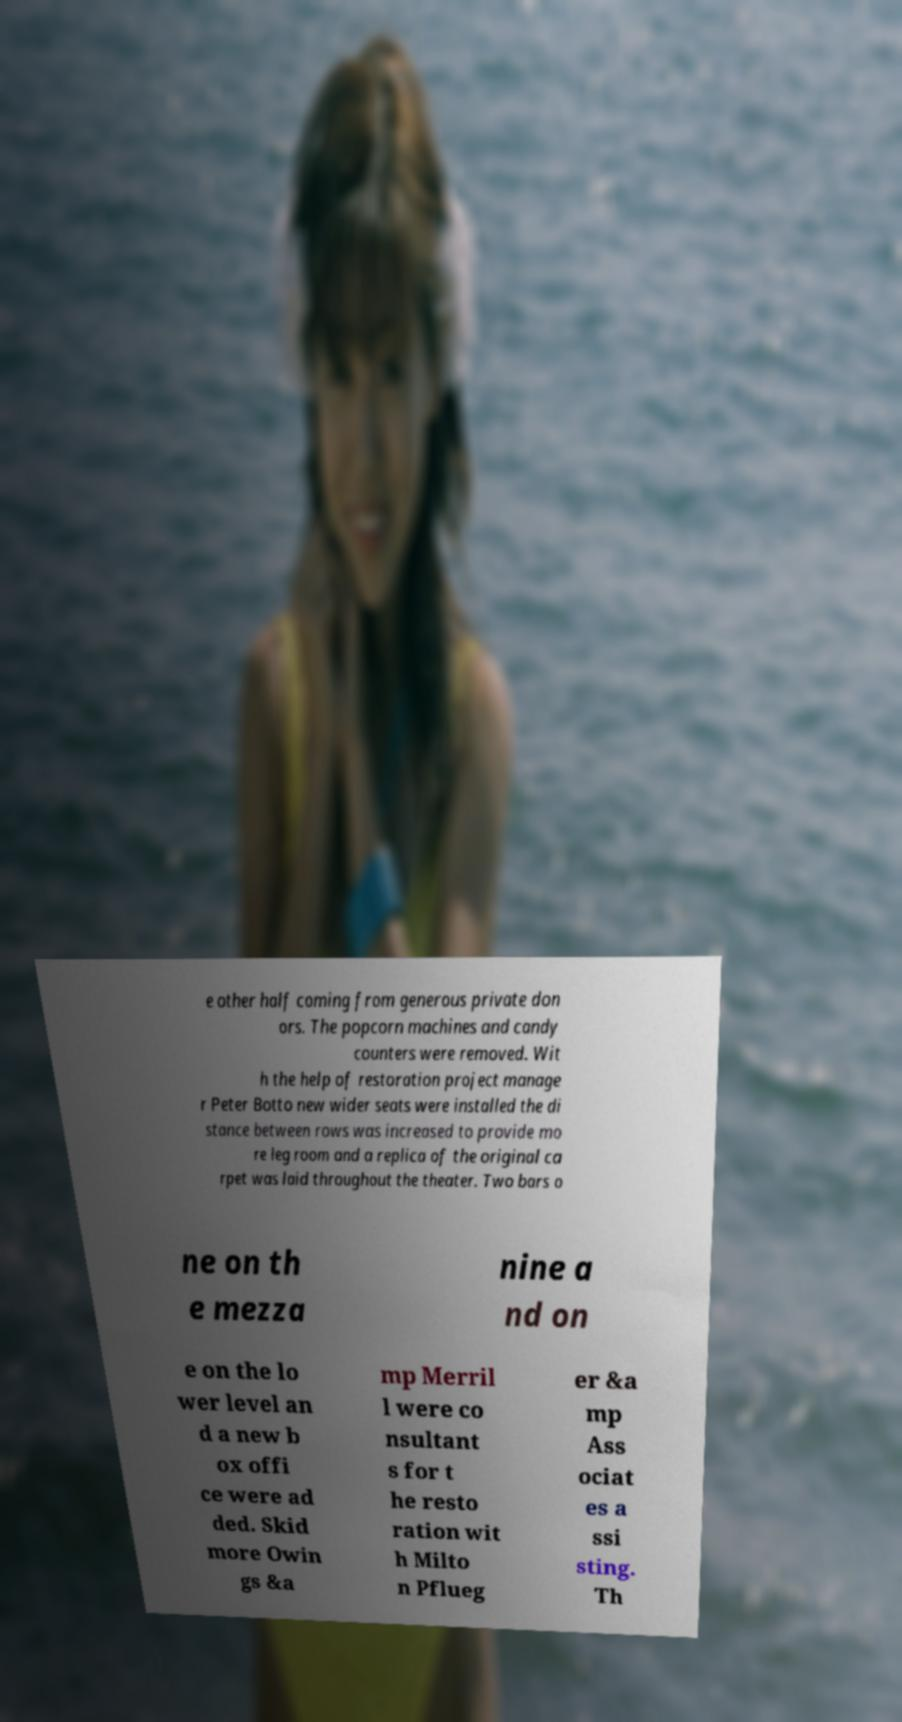Can you accurately transcribe the text from the provided image for me? e other half coming from generous private don ors. The popcorn machines and candy counters were removed. Wit h the help of restoration project manage r Peter Botto new wider seats were installed the di stance between rows was increased to provide mo re leg room and a replica of the original ca rpet was laid throughout the theater. Two bars o ne on th e mezza nine a nd on e on the lo wer level an d a new b ox offi ce were ad ded. Skid more Owin gs &a mp Merril l were co nsultant s for t he resto ration wit h Milto n Pflueg er &a mp Ass ociat es a ssi sting. Th 